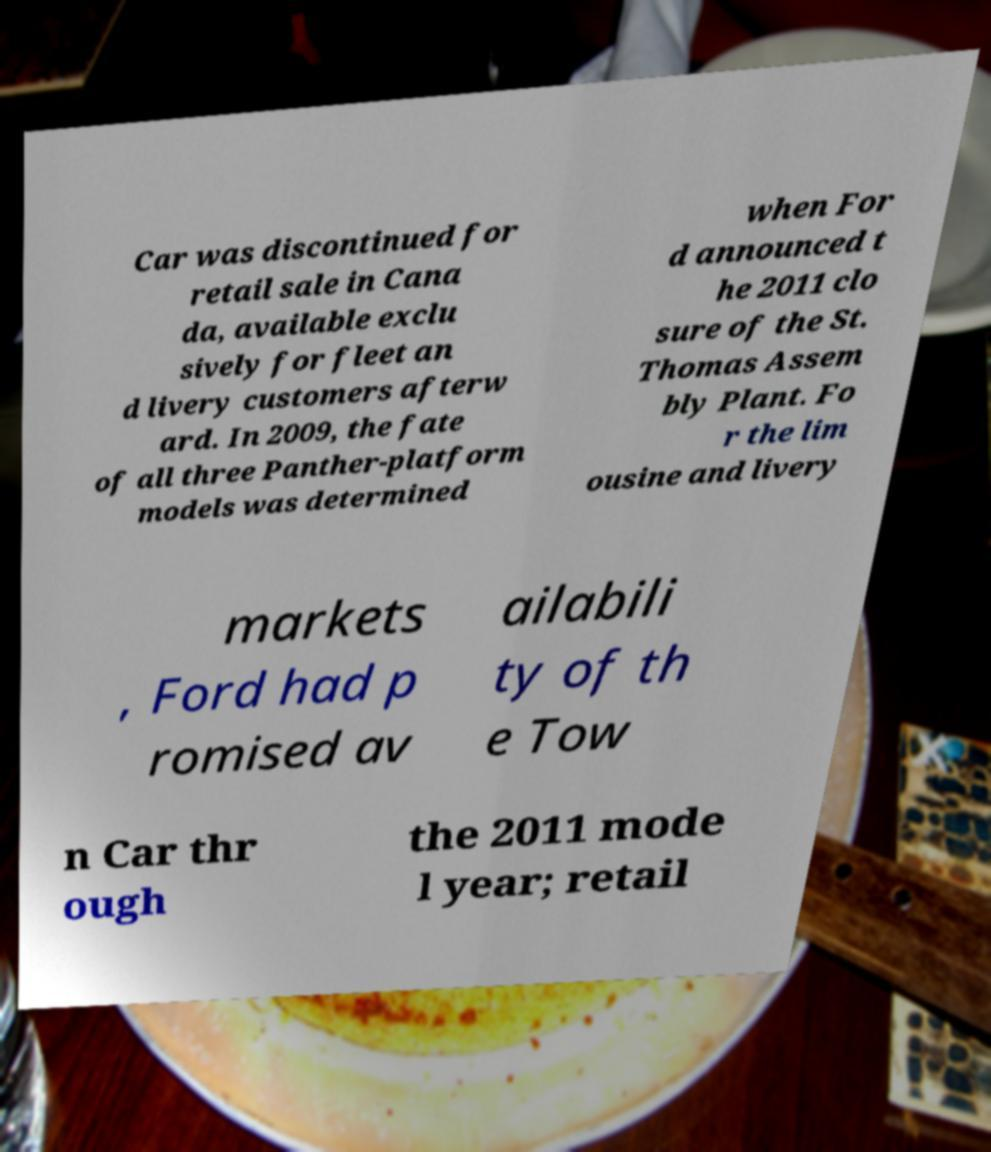For documentation purposes, I need the text within this image transcribed. Could you provide that? Car was discontinued for retail sale in Cana da, available exclu sively for fleet an d livery customers afterw ard. In 2009, the fate of all three Panther-platform models was determined when For d announced t he 2011 clo sure of the St. Thomas Assem bly Plant. Fo r the lim ousine and livery markets , Ford had p romised av ailabili ty of th e Tow n Car thr ough the 2011 mode l year; retail 